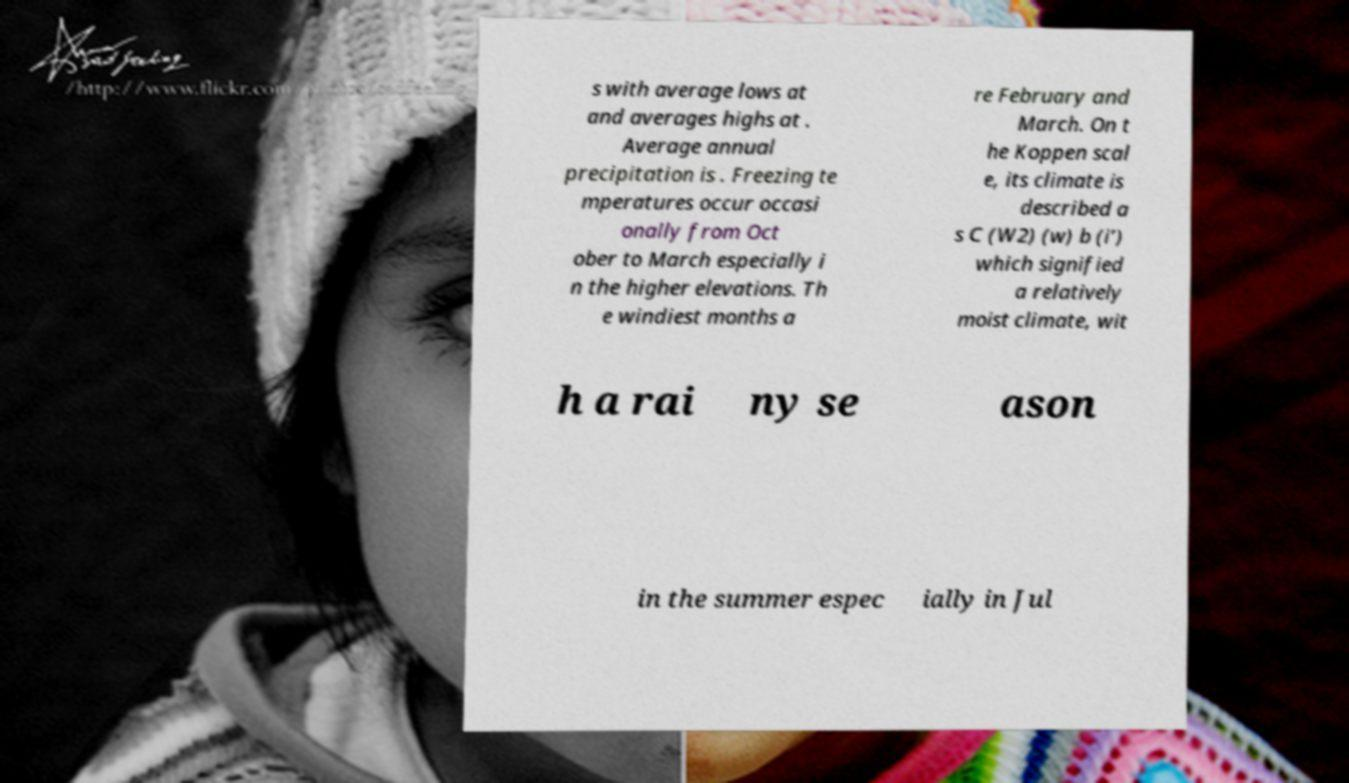Can you accurately transcribe the text from the provided image for me? s with average lows at and averages highs at . Average annual precipitation is . Freezing te mperatures occur occasi onally from Oct ober to March especially i n the higher elevations. Th e windiest months a re February and March. On t he Koppen scal e, its climate is described a s C (W2) (w) b (i’) which signified a relatively moist climate, wit h a rai ny se ason in the summer espec ially in Jul 